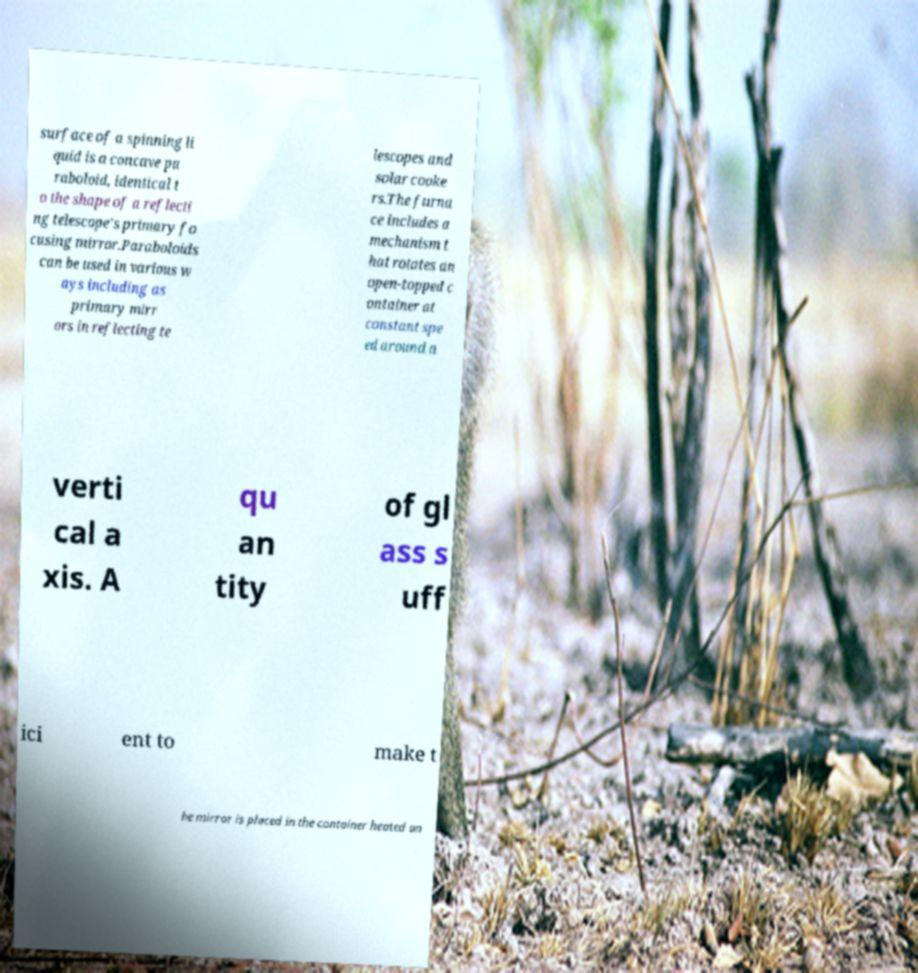Can you accurately transcribe the text from the provided image for me? surface of a spinning li quid is a concave pa raboloid, identical t o the shape of a reflecti ng telescope's primary fo cusing mirror.Paraboloids can be used in various w ays including as primary mirr ors in reflecting te lescopes and solar cooke rs.The furna ce includes a mechanism t hat rotates an open-topped c ontainer at constant spe ed around a verti cal a xis. A qu an tity of gl ass s uff ici ent to make t he mirror is placed in the container heated un 